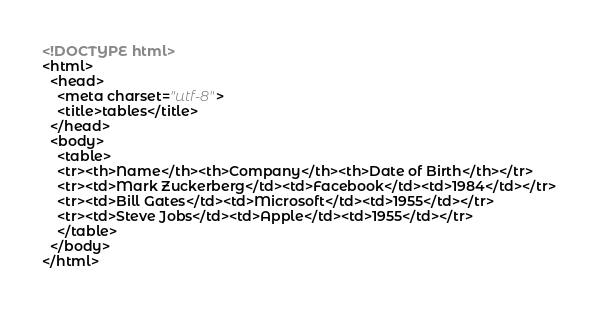Convert code to text. <code><loc_0><loc_0><loc_500><loc_500><_HTML_><!DOCTYPE html>
<html>
  <head>
    <meta charset="utf-8">
    <title>tables</title>
  </head>
  <body>
    <table>
    <tr><th>Name</th><th>Company</th><th>Date of Birth</th></tr>  
    <tr><td>Mark Zuckerberg</td><td>Facebook</td><td>1984</td></tr>
    <tr><td>Bill Gates</td><td>Microsoft</td><td>1955</td></tr>
    <tr><td>Steve Jobs</td><td>Apple</td><td>1955</td></tr>
    </table>
  </body>
</html></code> 